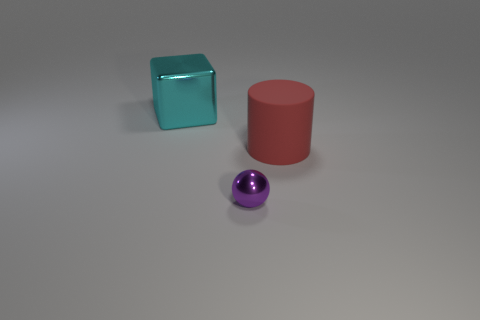Is there any other thing that is the same material as the red object?
Offer a very short reply. No. What is the material of the cylinder?
Your response must be concise. Rubber. Are the large thing behind the matte cylinder and the small sphere made of the same material?
Your response must be concise. Yes. There is a metallic thing in front of the big red matte cylinder; what is its shape?
Provide a short and direct response. Sphere. There is a cylinder that is the same size as the cyan block; what is it made of?
Your answer should be compact. Rubber. What number of things are either metallic things that are on the right side of the large cyan cube or shiny objects in front of the big metallic thing?
Give a very brief answer. 1. What size is the purple thing that is made of the same material as the large cyan block?
Give a very brief answer. Small. How many shiny objects are big blocks or small red objects?
Ensure brevity in your answer.  1. How big is the red rubber object?
Your response must be concise. Large. Does the metallic block have the same size as the ball?
Keep it short and to the point. No. 